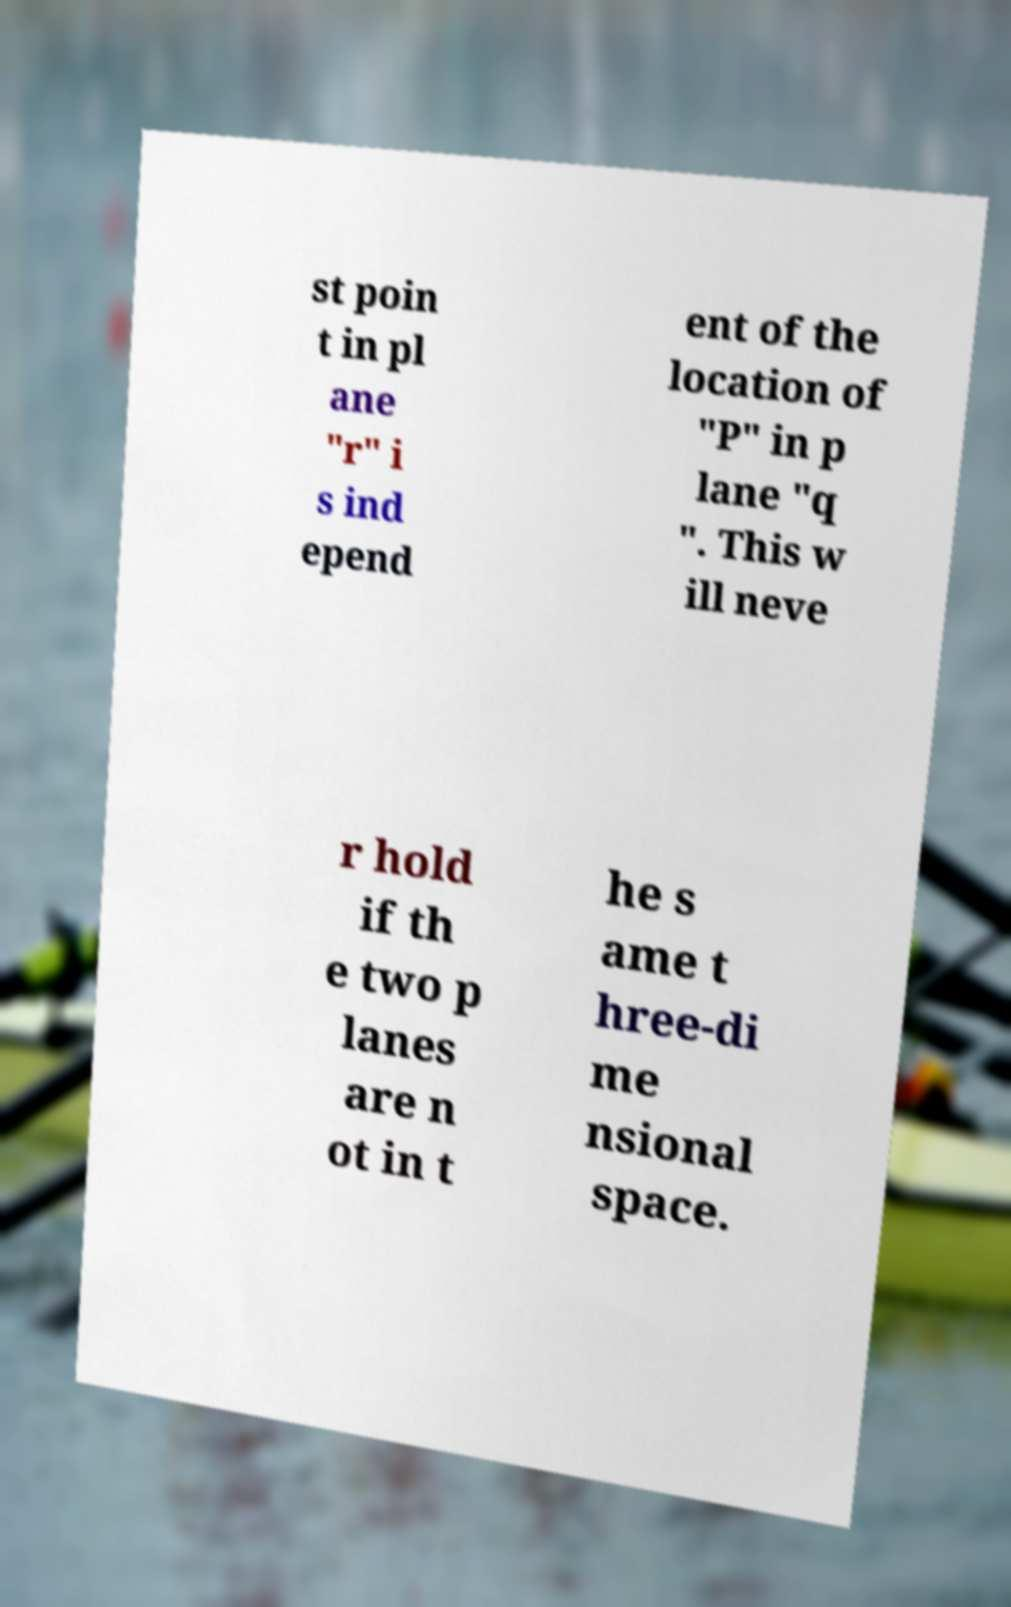What messages or text are displayed in this image? I need them in a readable, typed format. st poin t in pl ane "r" i s ind epend ent of the location of "P" in p lane "q ". This w ill neve r hold if th e two p lanes are n ot in t he s ame t hree-di me nsional space. 